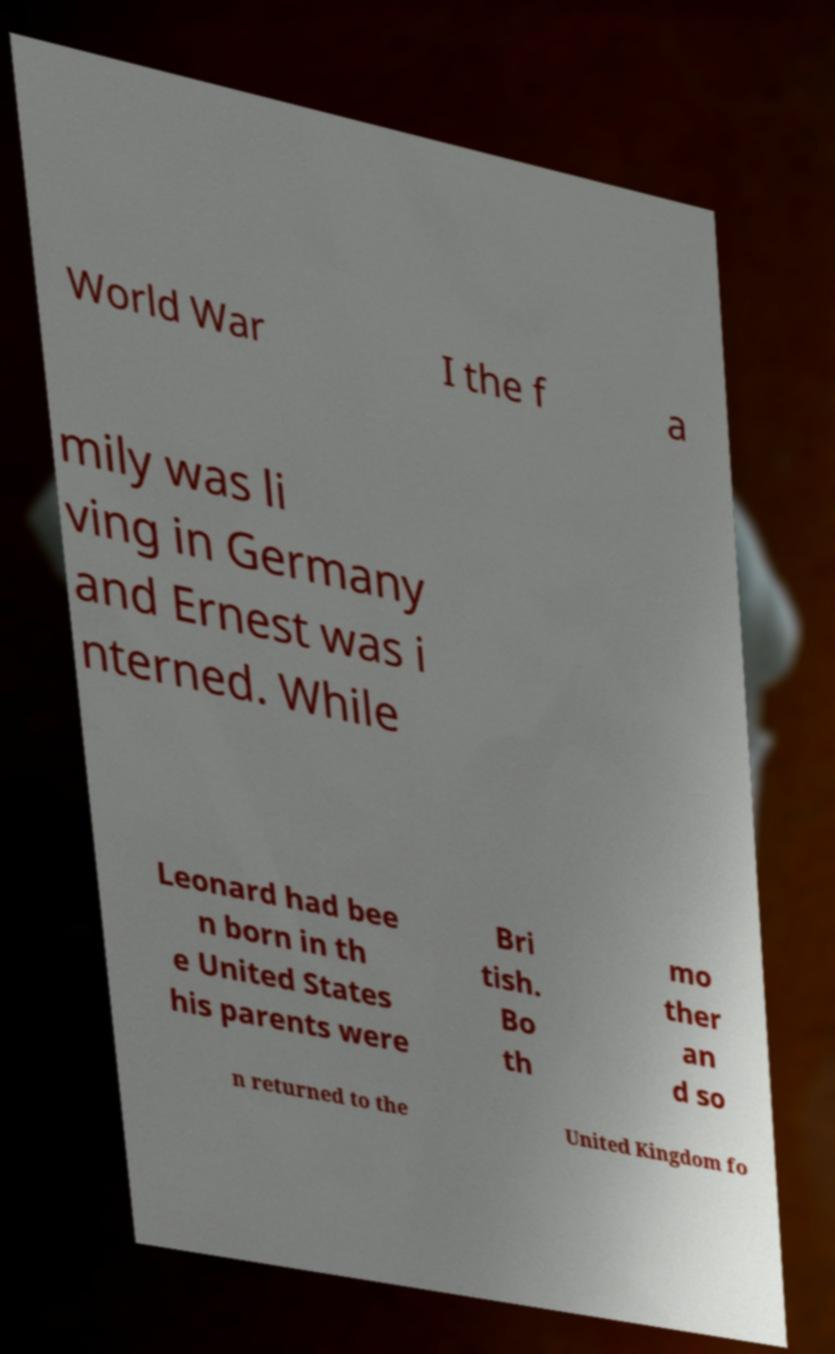What messages or text are displayed in this image? I need them in a readable, typed format. World War I the f a mily was li ving in Germany and Ernest was i nterned. While Leonard had bee n born in th e United States his parents were Bri tish. Bo th mo ther an d so n returned to the United Kingdom fo 